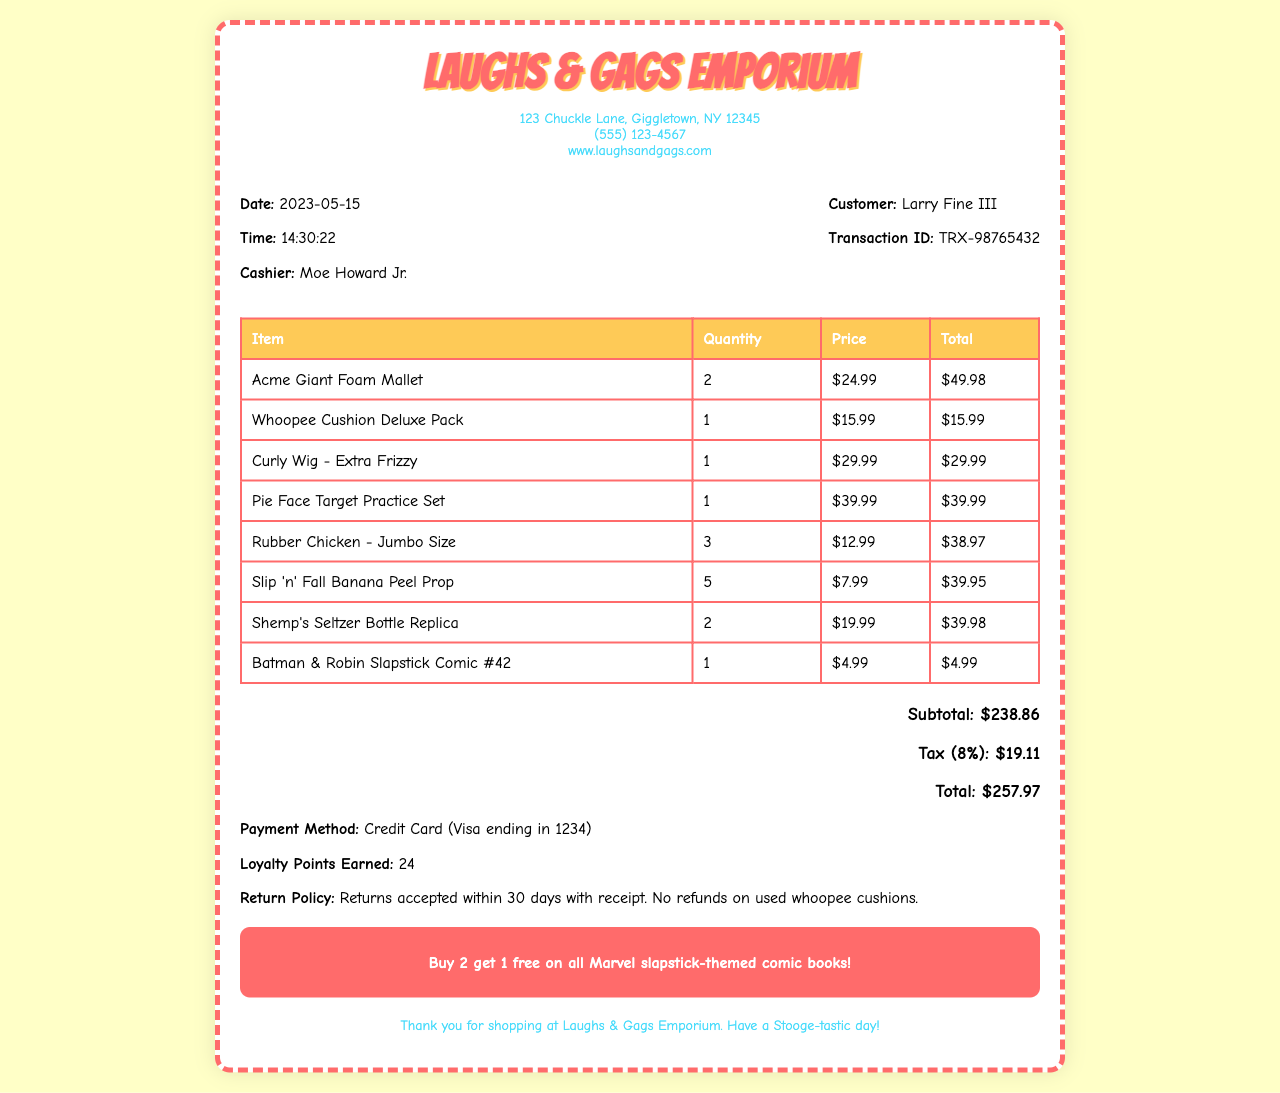What is the shop's name? The shop's name is prominently displayed at the top of the receipt.
Answer: Laughs & Gags Emporium Who was the cashier? The receipt provides the name of the cashier who handled the transaction.
Answer: Moe Howard Jr What item had the highest price? The prices of all items can be compared to determine which one is the most expensive.
Answer: Pie Face Target Practice Set What is the return policy? The document includes a specific statement outlining the return policy for purchases.
Answer: Returns accepted within 30 days with receipt. No refunds on used whoopee cushions What was the total amount spent? The total amount is calculated with the subtotal and tax provided on the receipt.
Answer: $257.97 How many loyalty points were earned? The receipt mentions the number of loyalty points gained from the purchase.
Answer: 24 What is the tax rate applied? The tax rate is specified as a percentage on the receipt.
Answer: 8% What special offer is mentioned? The document highlights a promotional offer related to comic books.
Answer: Buy 2 get 1 free on all Marvel slapstick-themed comic books! 